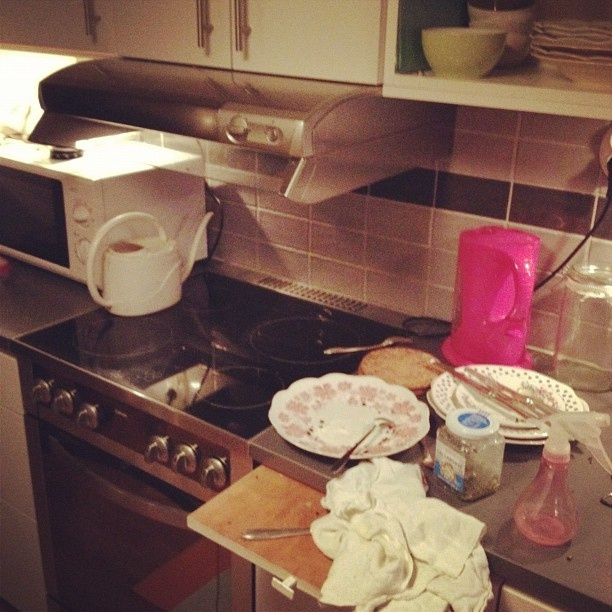Describe the objects in this image and their specific colors. I can see oven in brown, black, and maroon tones, microwave in brown, gray, black, ivory, and tan tones, bottle in brown and tan tones, bowl in brown, olive, and maroon tones, and bowl in brown, maroon, and black tones in this image. 